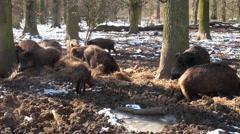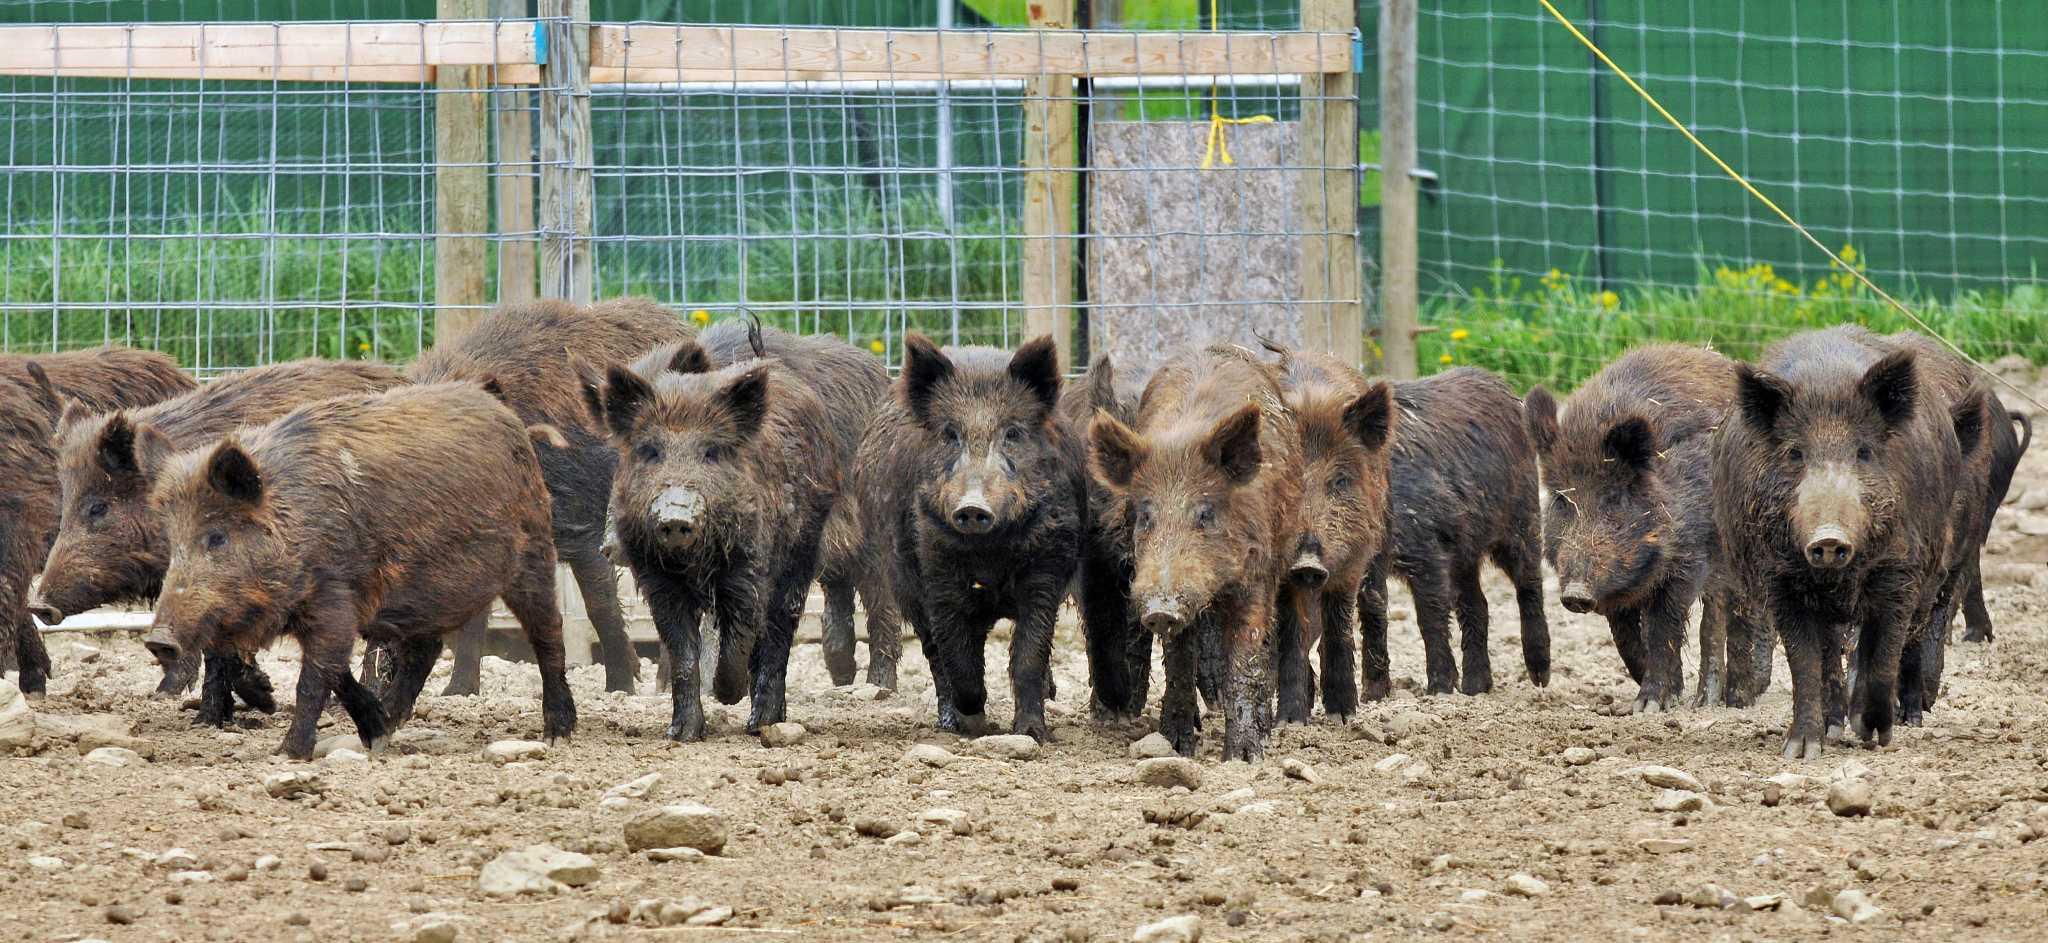The first image is the image on the left, the second image is the image on the right. Evaluate the accuracy of this statement regarding the images: "The right image contains a hunter posing with a dead boar.". Is it true? Answer yes or no. No. The first image is the image on the left, the second image is the image on the right. Evaluate the accuracy of this statement regarding the images: "At least one man is standing behind a dead wild boar holding a gun.". Is it true? Answer yes or no. No. 